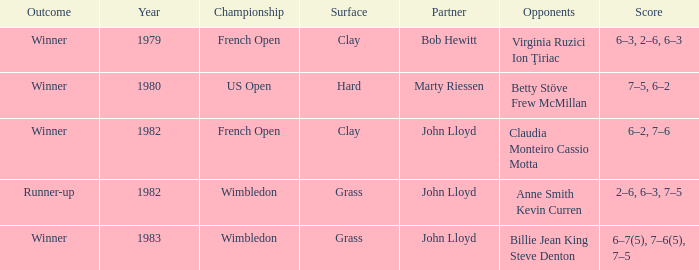On a clay surface, what was the total quantity of matches that ended with a winner, and included a partner of john lloyd? 1.0. 